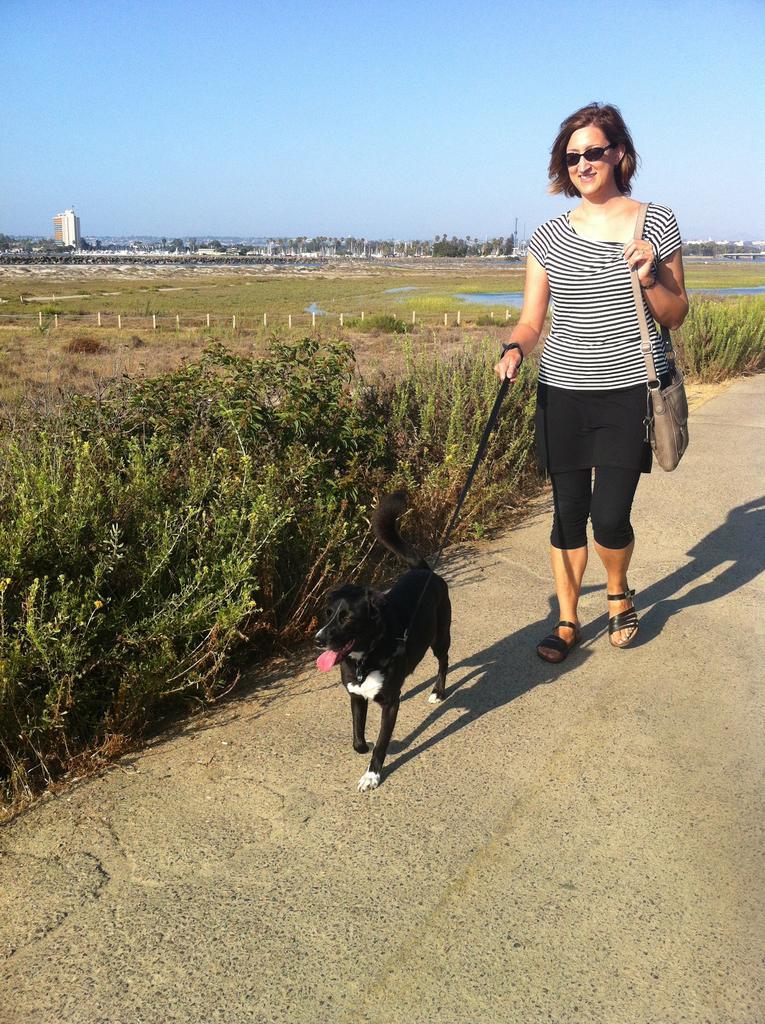How would you summarize this image in a sentence or two? In this picture we can see a woman carrying a bag and holding a belt of a dog with her hand and walking on the road, grass, plants, poles, trees, building and some objects and in the background we can see the sky. 